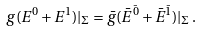<formula> <loc_0><loc_0><loc_500><loc_500>g ( E ^ { 0 } + E ^ { 1 } ) | _ { \Sigma } = \bar { g } ( \bar { E } ^ { \bar { 0 } } + \bar { E } ^ { \bar { 1 } } ) | _ { \Sigma } \, .</formula> 